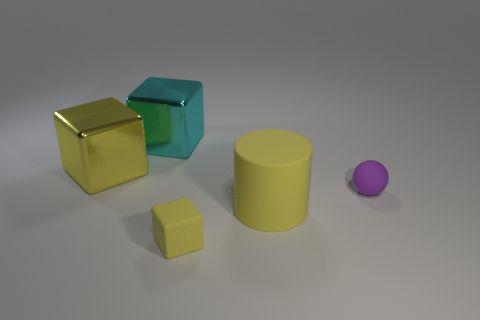There is a tiny cube that is the same color as the matte cylinder; what is it made of?
Provide a succinct answer. Rubber. Does the yellow rubber cube have the same size as the thing that is left of the big cyan block?
Ensure brevity in your answer.  No. There is a yellow thing that is behind the small matte thing on the right side of the yellow block to the right of the big yellow metal cube; how big is it?
Offer a very short reply. Large. How many rubber balls are in front of the yellow cylinder?
Your answer should be very brief. 0. What is the material of the yellow object that is left of the cube that is in front of the ball?
Keep it short and to the point. Metal. Is there anything else that has the same size as the cyan thing?
Keep it short and to the point. Yes. Is the matte cube the same size as the matte ball?
Provide a short and direct response. Yes. What number of objects are either tiny rubber things in front of the matte cylinder or large yellow metal blocks behind the small purple object?
Make the answer very short. 2. Are there more large yellow rubber objects behind the large yellow matte cylinder than big yellow cylinders?
Offer a very short reply. No. How many other objects are the same shape as the yellow metal thing?
Offer a terse response. 2. 